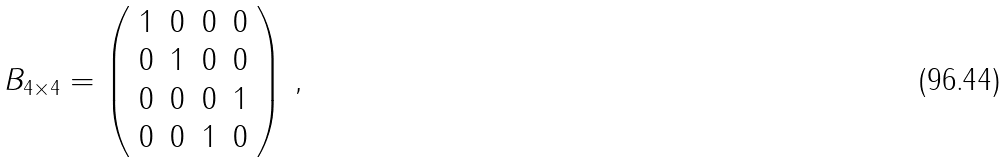Convert formula to latex. <formula><loc_0><loc_0><loc_500><loc_500>B _ { 4 \times 4 } = \left ( \begin{array} { c c c c } 1 & 0 & 0 & 0 \\ 0 & 1 & 0 & 0 \\ 0 & 0 & 0 & 1 \\ 0 & 0 & 1 & 0 \end{array} \right ) \, ,</formula> 